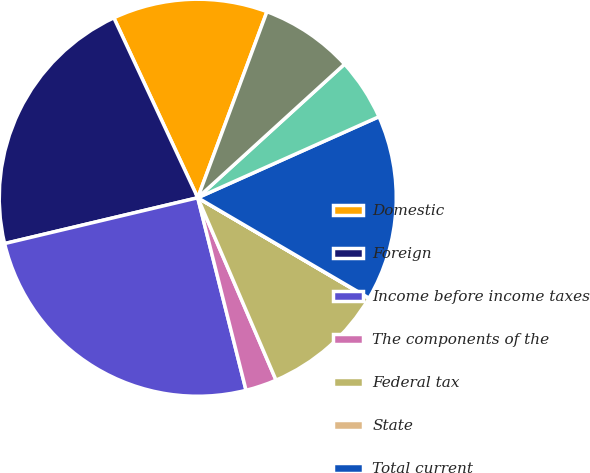<chart> <loc_0><loc_0><loc_500><loc_500><pie_chart><fcel>Domestic<fcel>Foreign<fcel>Income before income taxes<fcel>The components of the<fcel>Federal tax<fcel>State<fcel>Total current<fcel>Federal<fcel>Total deferred<nl><fcel>12.61%<fcel>21.76%<fcel>25.2%<fcel>2.54%<fcel>10.09%<fcel>0.02%<fcel>15.13%<fcel>5.06%<fcel>7.58%<nl></chart> 